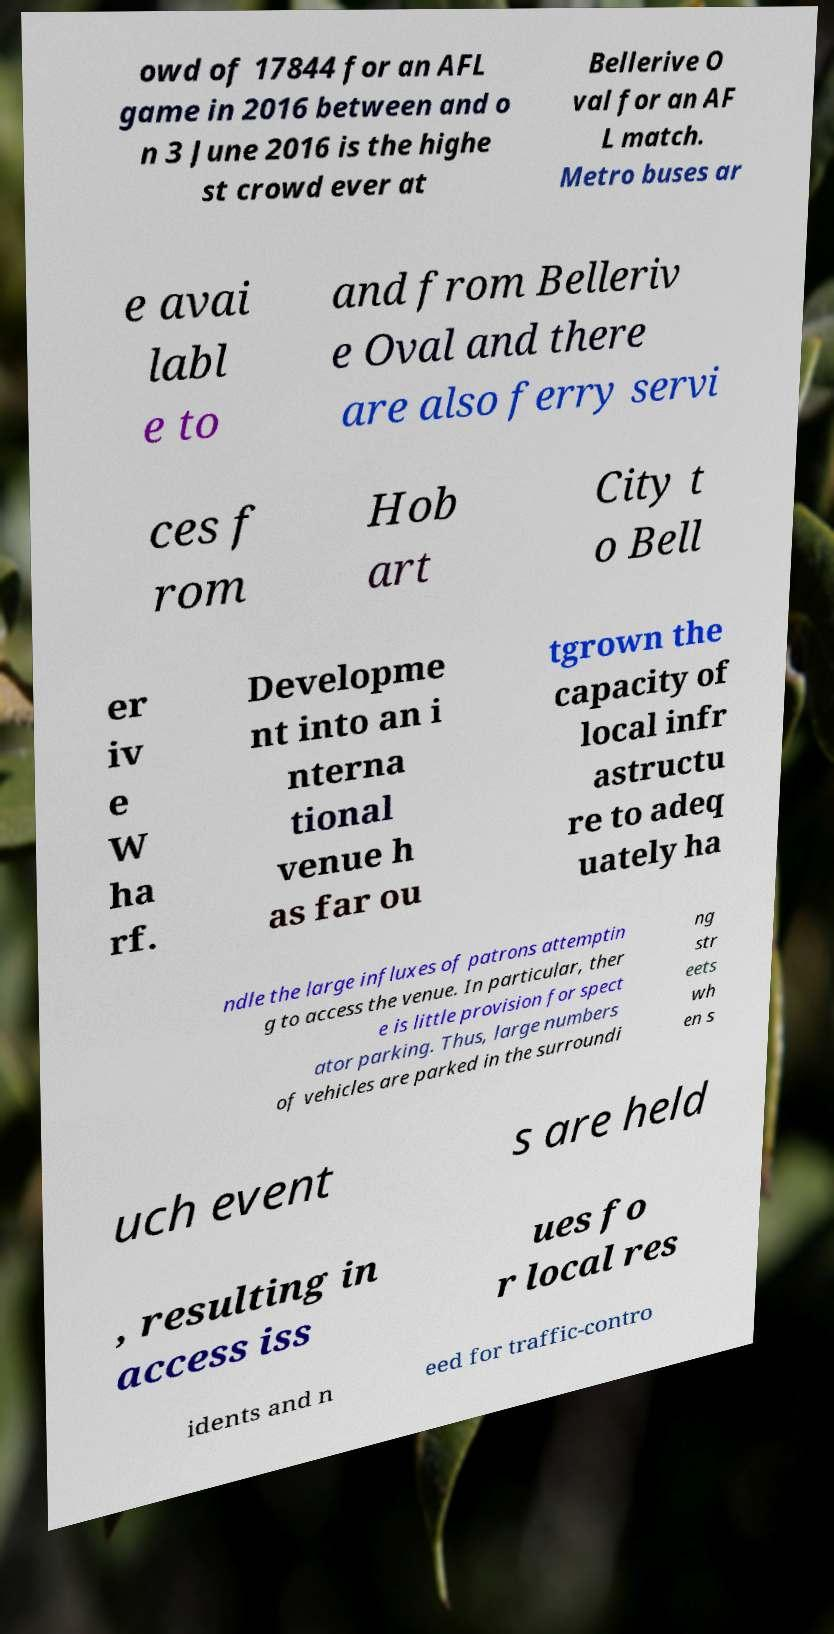Please identify and transcribe the text found in this image. owd of 17844 for an AFL game in 2016 between and o n 3 June 2016 is the highe st crowd ever at Bellerive O val for an AF L match. Metro buses ar e avai labl e to and from Belleriv e Oval and there are also ferry servi ces f rom Hob art City t o Bell er iv e W ha rf. Developme nt into an i nterna tional venue h as far ou tgrown the capacity of local infr astructu re to adeq uately ha ndle the large influxes of patrons attemptin g to access the venue. In particular, ther e is little provision for spect ator parking. Thus, large numbers of vehicles are parked in the surroundi ng str eets wh en s uch event s are held , resulting in access iss ues fo r local res idents and n eed for traffic-contro 